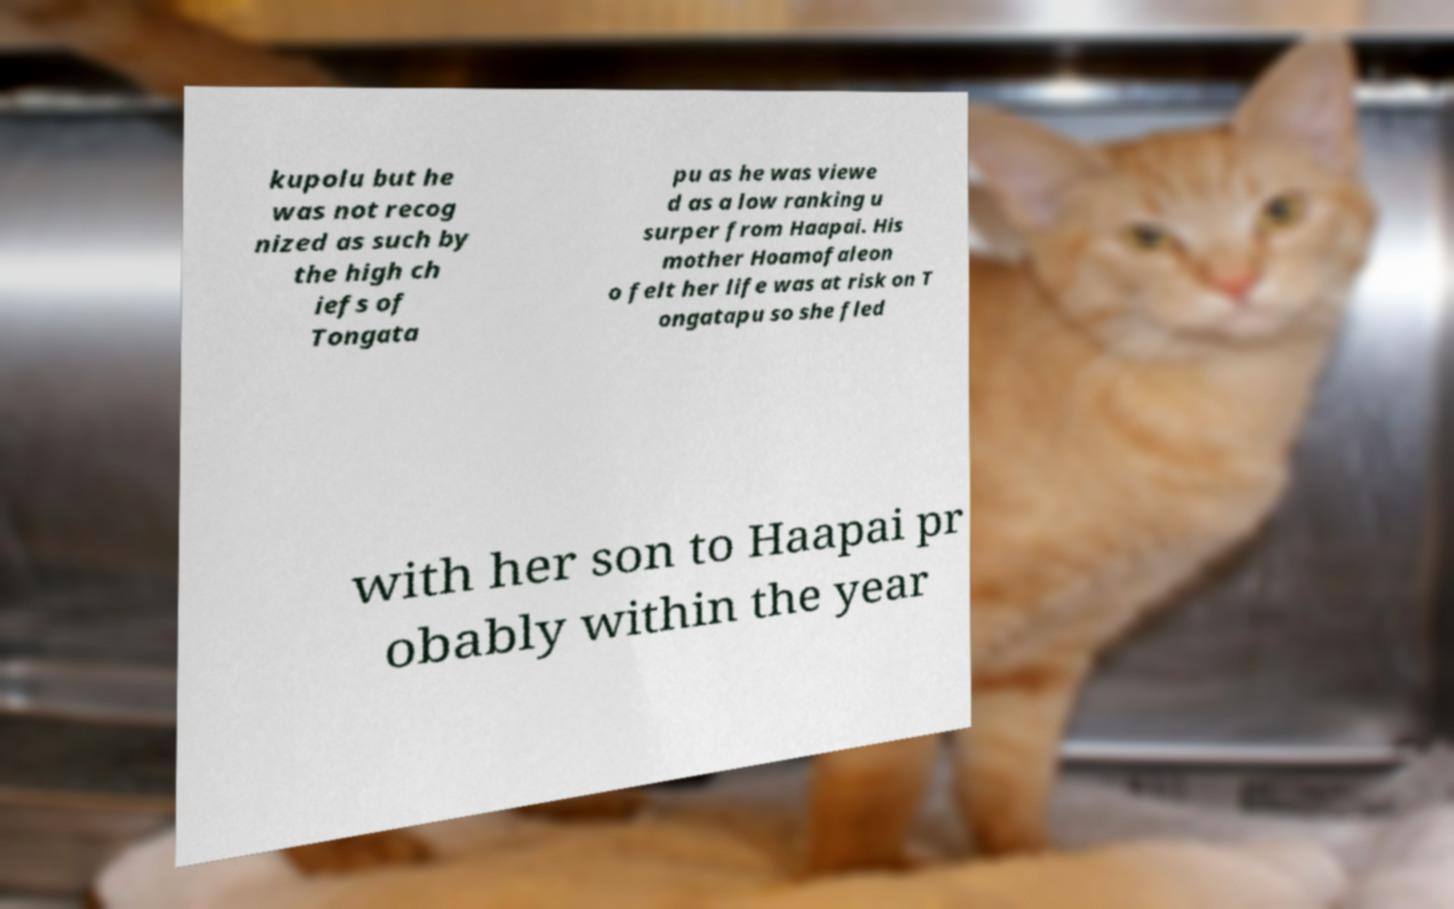Can you read and provide the text displayed in the image?This photo seems to have some interesting text. Can you extract and type it out for me? kupolu but he was not recog nized as such by the high ch iefs of Tongata pu as he was viewe d as a low ranking u surper from Haapai. His mother Hoamofaleon o felt her life was at risk on T ongatapu so she fled with her son to Haapai pr obably within the year 